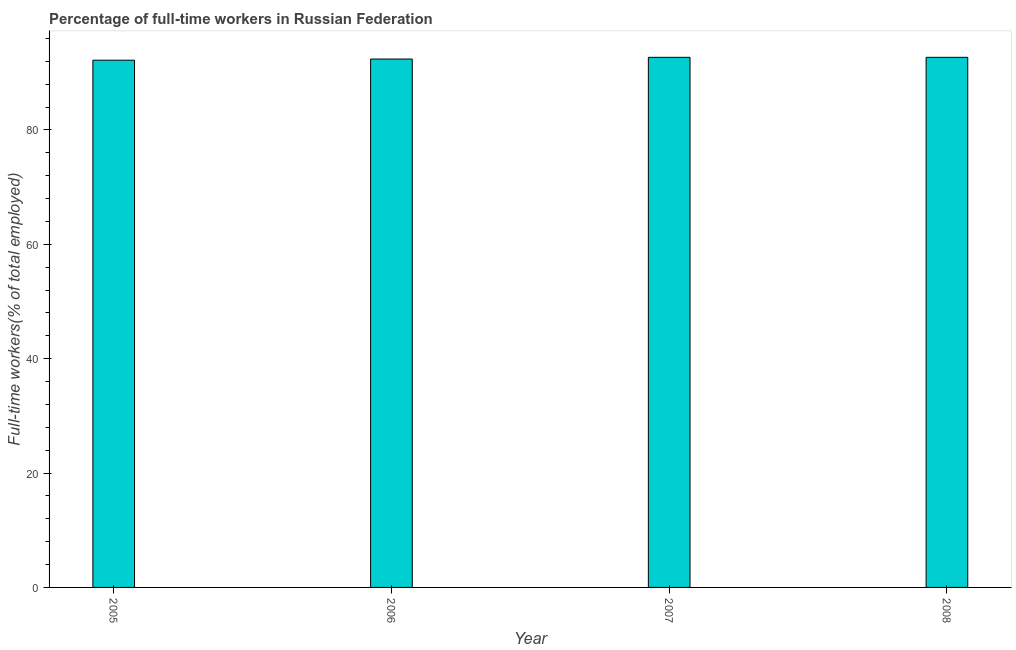Does the graph contain any zero values?
Make the answer very short. No. Does the graph contain grids?
Your answer should be very brief. No. What is the title of the graph?
Your response must be concise. Percentage of full-time workers in Russian Federation. What is the label or title of the Y-axis?
Keep it short and to the point. Full-time workers(% of total employed). What is the percentage of full-time workers in 2007?
Provide a short and direct response. 92.7. Across all years, what is the maximum percentage of full-time workers?
Offer a terse response. 92.7. Across all years, what is the minimum percentage of full-time workers?
Provide a succinct answer. 92.2. In which year was the percentage of full-time workers maximum?
Make the answer very short. 2007. In which year was the percentage of full-time workers minimum?
Offer a very short reply. 2005. What is the sum of the percentage of full-time workers?
Provide a short and direct response. 370. What is the difference between the percentage of full-time workers in 2007 and 2008?
Keep it short and to the point. 0. What is the average percentage of full-time workers per year?
Provide a short and direct response. 92.5. What is the median percentage of full-time workers?
Your answer should be very brief. 92.55. Is the percentage of full-time workers in 2005 less than that in 2008?
Give a very brief answer. Yes. What is the difference between the highest and the lowest percentage of full-time workers?
Offer a very short reply. 0.5. In how many years, is the percentage of full-time workers greater than the average percentage of full-time workers taken over all years?
Give a very brief answer. 2. Are all the bars in the graph horizontal?
Your answer should be compact. No. What is the Full-time workers(% of total employed) in 2005?
Make the answer very short. 92.2. What is the Full-time workers(% of total employed) of 2006?
Your response must be concise. 92.4. What is the Full-time workers(% of total employed) in 2007?
Ensure brevity in your answer.  92.7. What is the Full-time workers(% of total employed) of 2008?
Your response must be concise. 92.7. What is the difference between the Full-time workers(% of total employed) in 2005 and 2006?
Your answer should be very brief. -0.2. What is the difference between the Full-time workers(% of total employed) in 2005 and 2008?
Your answer should be very brief. -0.5. What is the difference between the Full-time workers(% of total employed) in 2006 and 2007?
Offer a terse response. -0.3. What is the difference between the Full-time workers(% of total employed) in 2007 and 2008?
Provide a short and direct response. 0. What is the ratio of the Full-time workers(% of total employed) in 2005 to that in 2006?
Offer a very short reply. 1. What is the ratio of the Full-time workers(% of total employed) in 2005 to that in 2007?
Your answer should be compact. 0.99. What is the ratio of the Full-time workers(% of total employed) in 2005 to that in 2008?
Keep it short and to the point. 0.99. What is the ratio of the Full-time workers(% of total employed) in 2006 to that in 2007?
Your response must be concise. 1. 